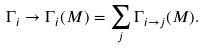<formula> <loc_0><loc_0><loc_500><loc_500>\Gamma _ { i } \to \Gamma _ { i } ( M ) = \sum _ { j } \Gamma _ { i \to j } ( M ) .</formula> 